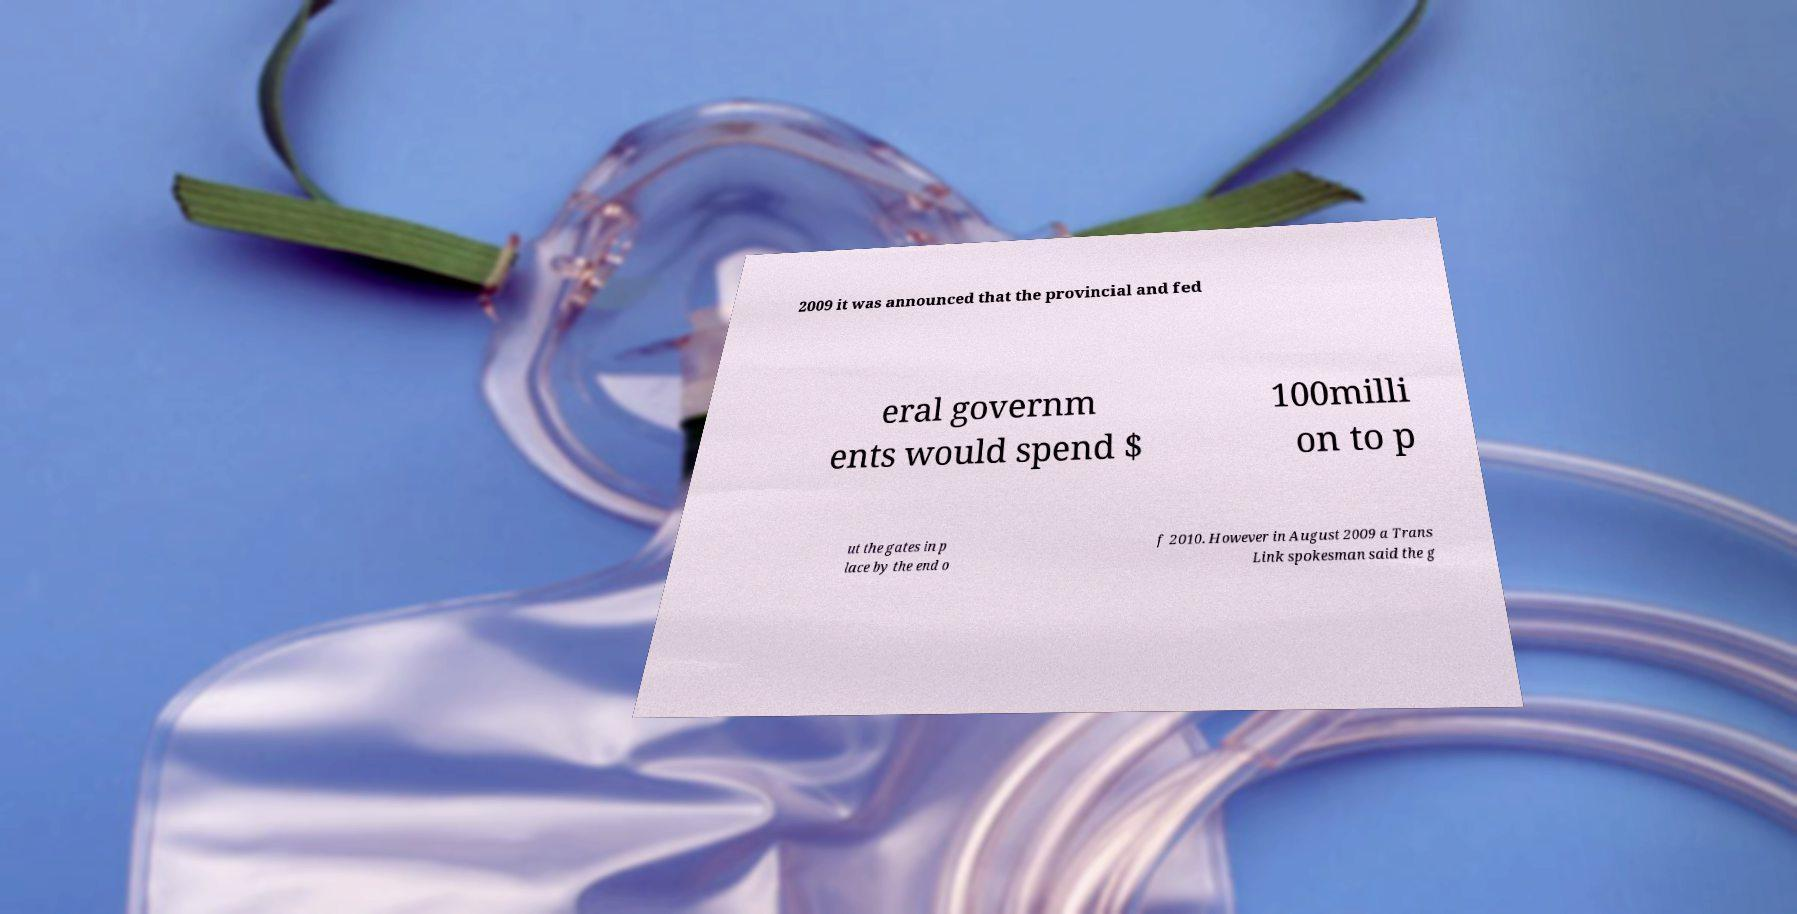There's text embedded in this image that I need extracted. Can you transcribe it verbatim? 2009 it was announced that the provincial and fed eral governm ents would spend $ 100milli on to p ut the gates in p lace by the end o f 2010. However in August 2009 a Trans Link spokesman said the g 